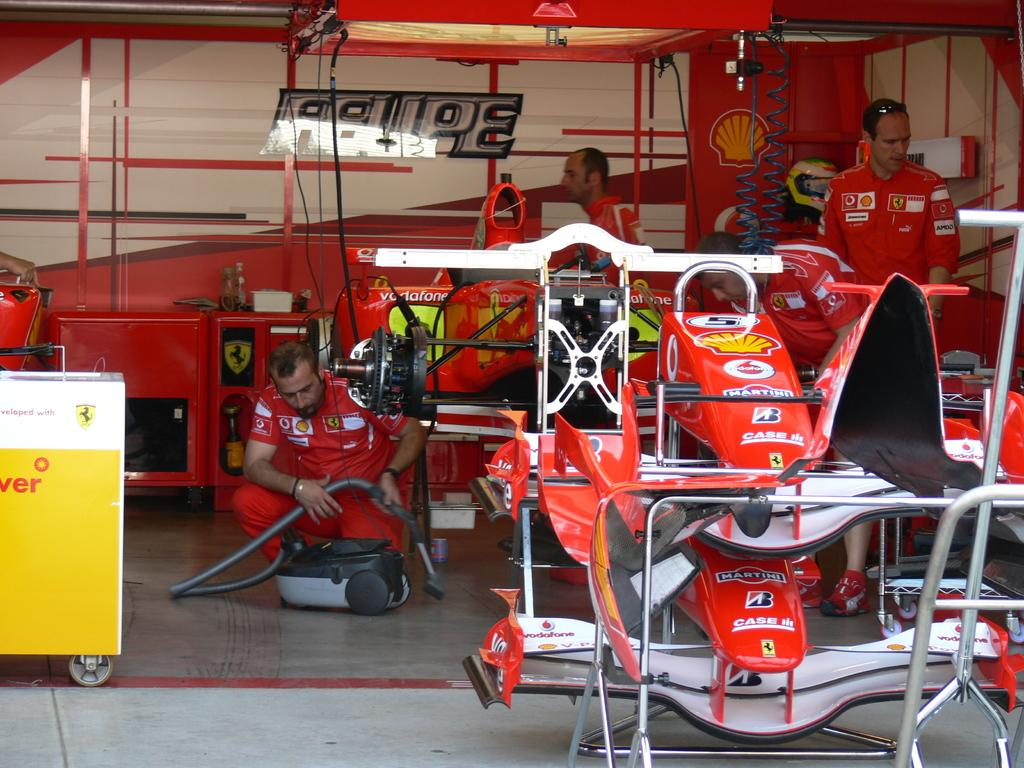Who or what can be seen in the image? There are people and machines in the image. What is the man holding in the image? The man is holding a vacuum cleaner. What can be seen in the background of the image? There are metal rods in the background of the image. What is the profit margin of the company depicted in the image? There is no information about the company or its profit margin in the image. What thought is the person in the image having? The image does not provide any information about the thoughts of the person in the image. 